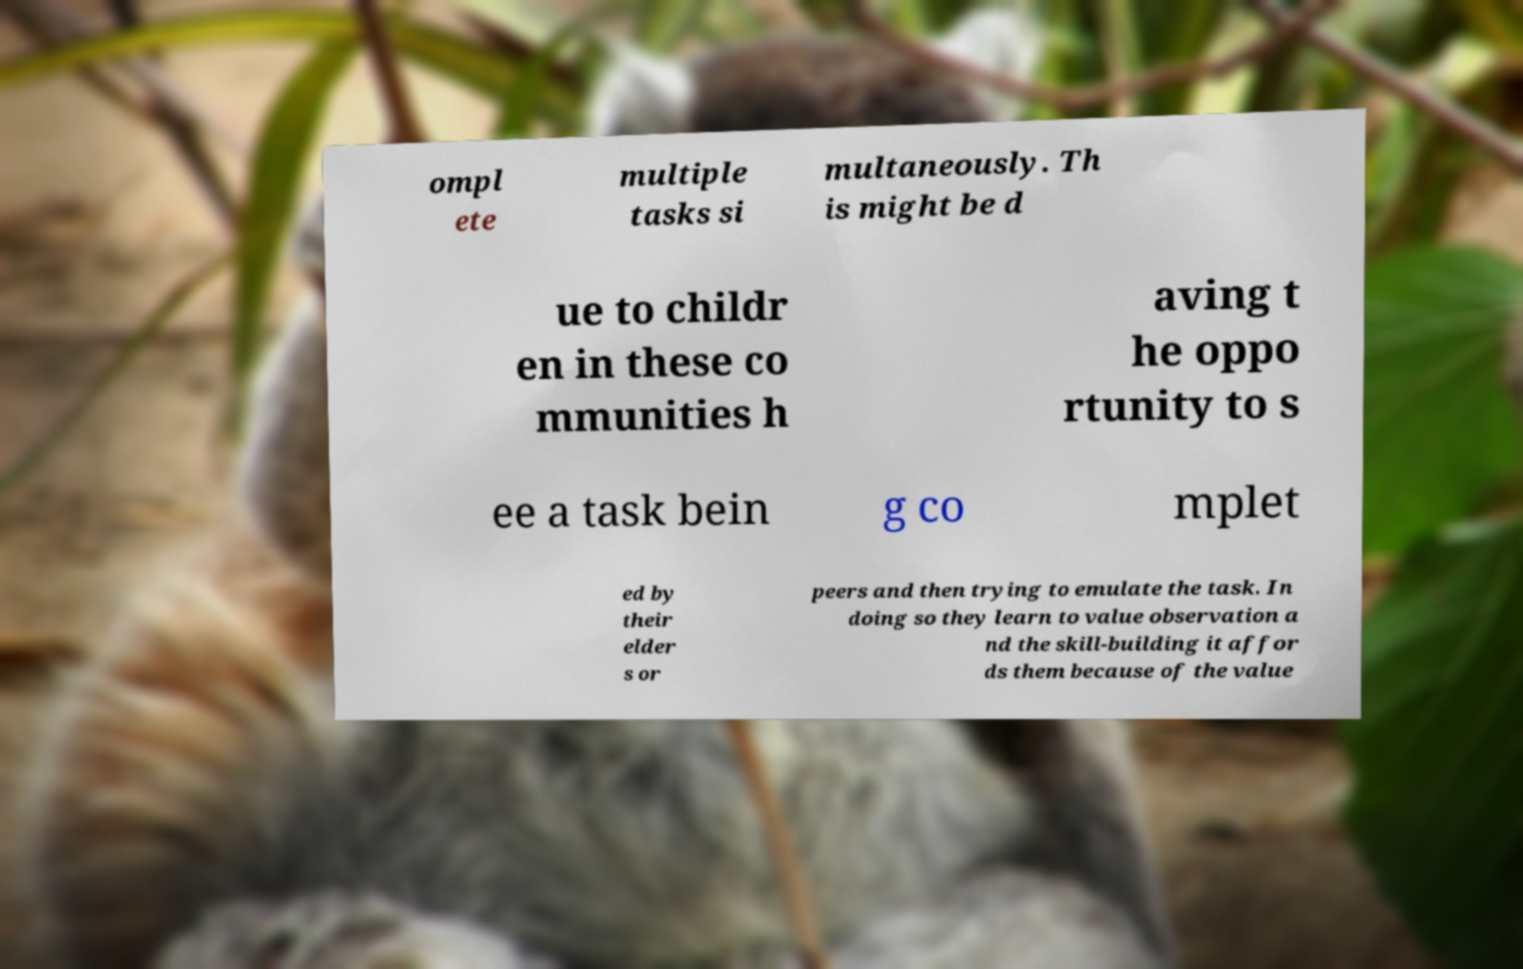Can you accurately transcribe the text from the provided image for me? ompl ete multiple tasks si multaneously. Th is might be d ue to childr en in these co mmunities h aving t he oppo rtunity to s ee a task bein g co mplet ed by their elder s or peers and then trying to emulate the task. In doing so they learn to value observation a nd the skill-building it affor ds them because of the value 